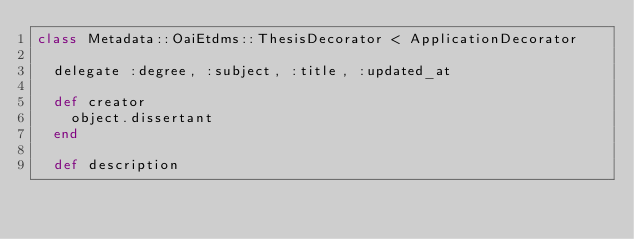<code> <loc_0><loc_0><loc_500><loc_500><_Ruby_>class Metadata::OaiEtdms::ThesisDecorator < ApplicationDecorator

  delegate :degree, :subject, :title, :updated_at

  def creator
    object.dissertant
  end

  def description</code> 